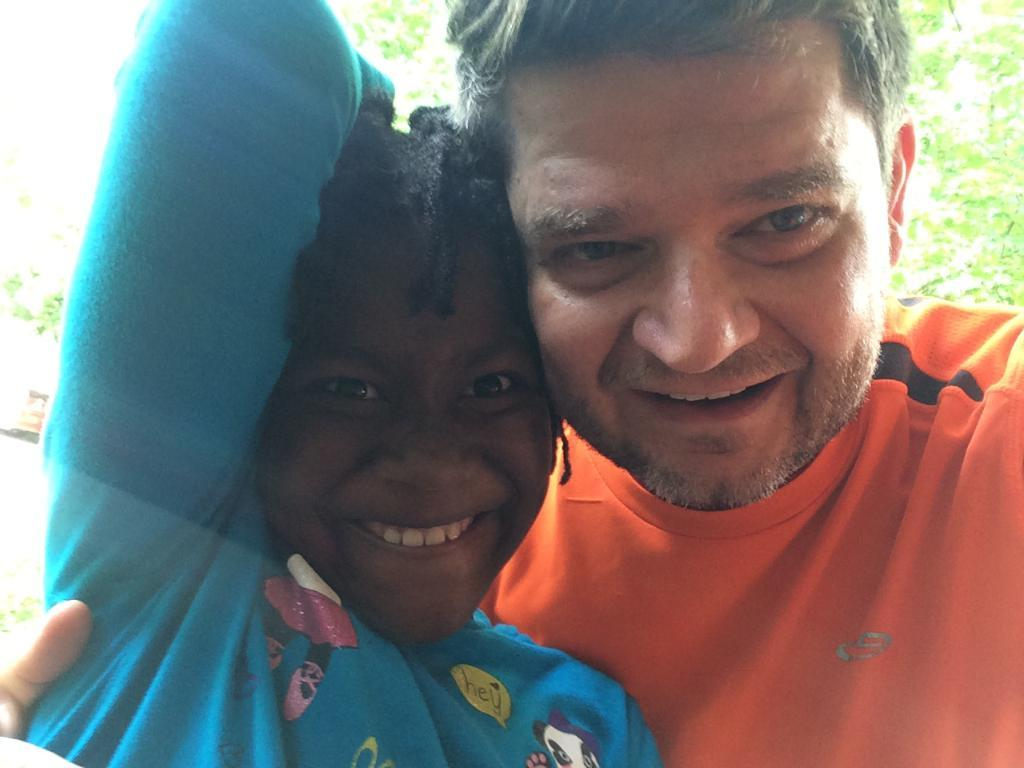What are the people in the image wearing? The man is wearing an orange T-shirt, and the girl is wearing a blue T-shirt in the image. What are the people in the image doing? Both the man and the girl are posing for a photo. What expressions do the people in the image have? Both the man and the girl are smiling. What can be seen in the background of the image? There are trees in the background of the image. How many pizzas are visible in the image? There are no pizzas present in the image. What type of error can be seen in the image? There is no error visible in the image. 